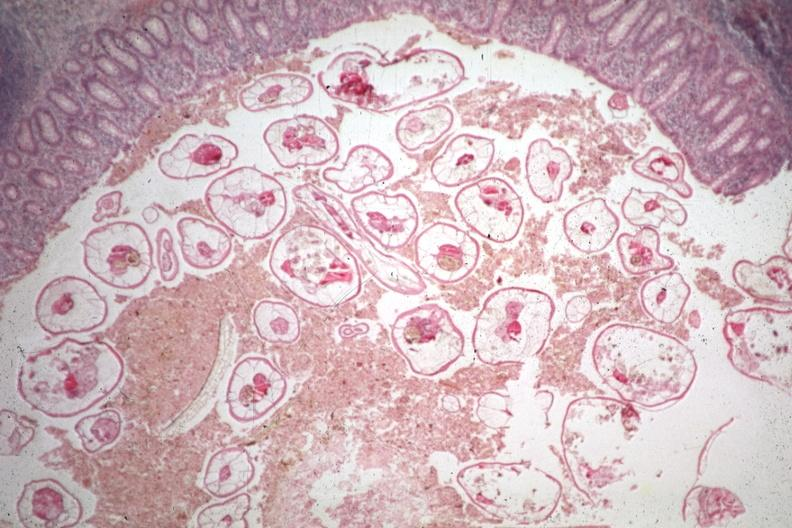where is this from?
Answer the question using a single word or phrase. Gastrointestinal system 